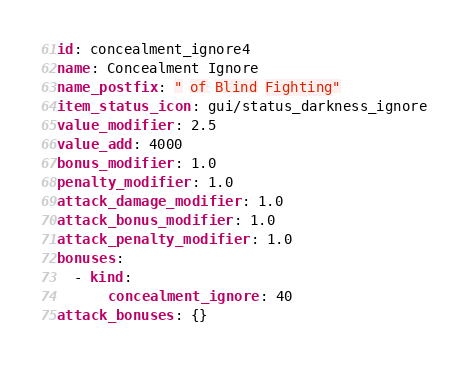Convert code to text. <code><loc_0><loc_0><loc_500><loc_500><_YAML_>id: concealment_ignore4
name: Concealment Ignore
name_postfix: " of Blind Fighting"
item_status_icon: gui/status_darkness_ignore
value_modifier: 2.5
value_add: 4000
bonus_modifier: 1.0
penalty_modifier: 1.0
attack_damage_modifier: 1.0
attack_bonus_modifier: 1.0
attack_penalty_modifier: 1.0
bonuses:
  - kind:
      concealment_ignore: 40
attack_bonuses: {}
</code> 